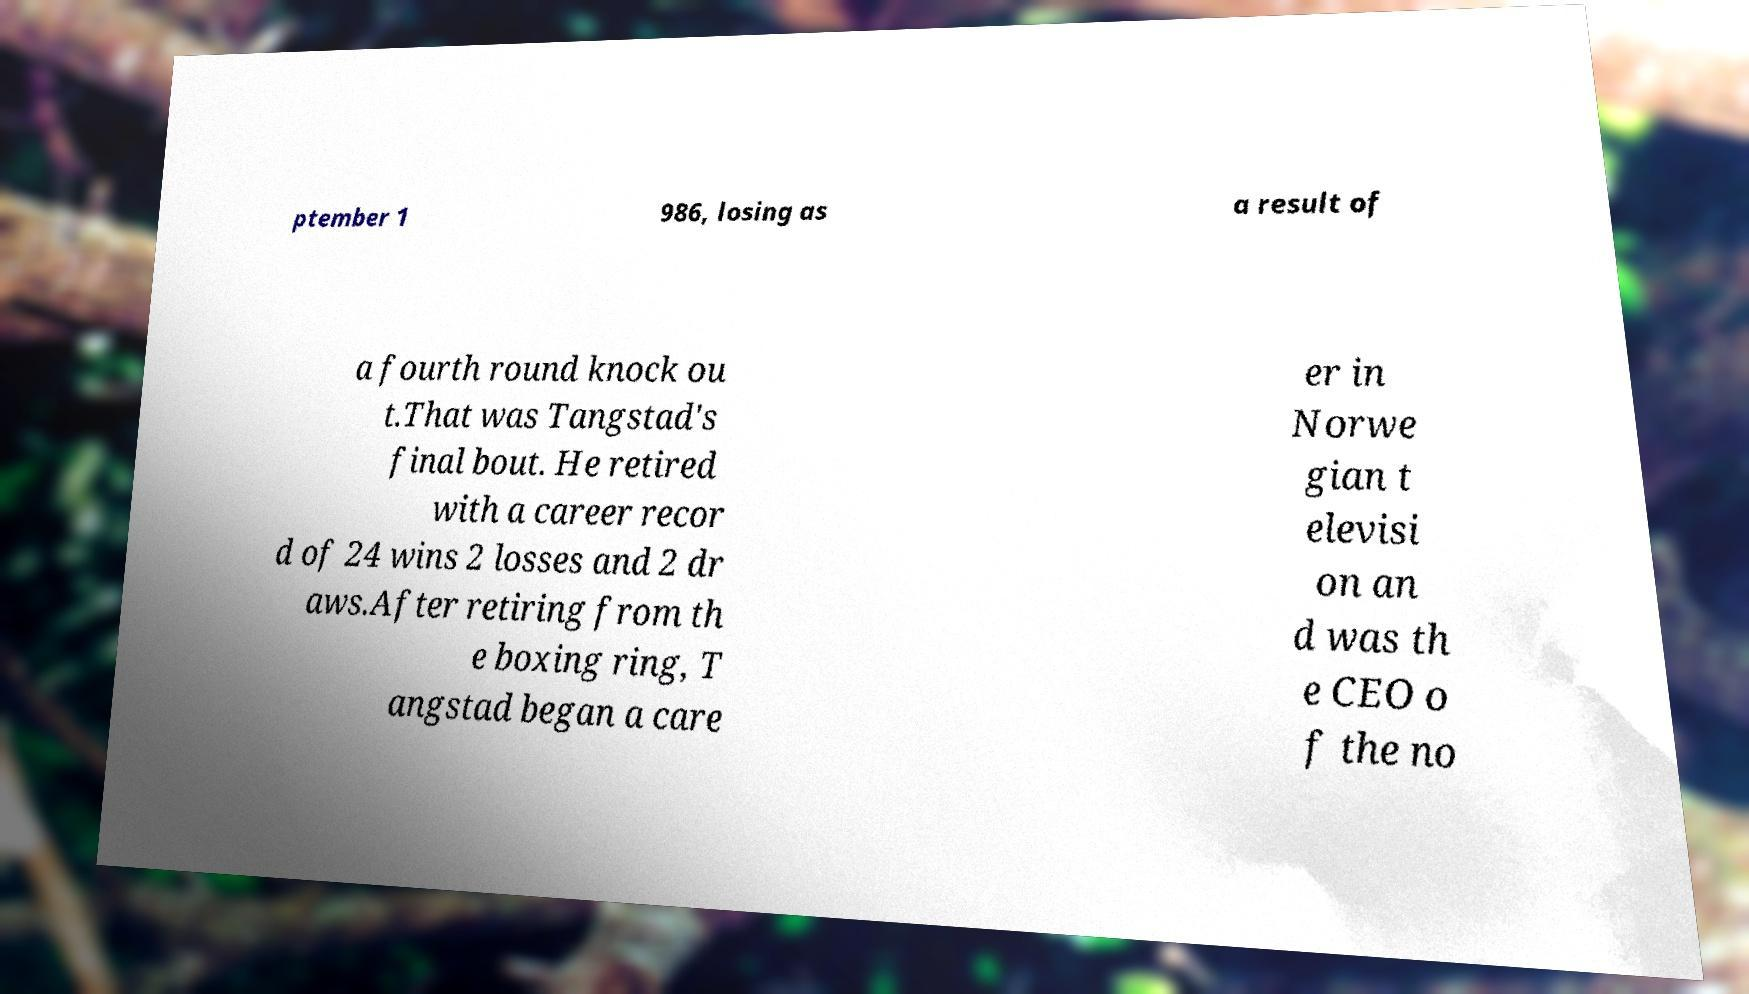What messages or text are displayed in this image? I need them in a readable, typed format. ptember 1 986, losing as a result of a fourth round knock ou t.That was Tangstad's final bout. He retired with a career recor d of 24 wins 2 losses and 2 dr aws.After retiring from th e boxing ring, T angstad began a care er in Norwe gian t elevisi on an d was th e CEO o f the no 